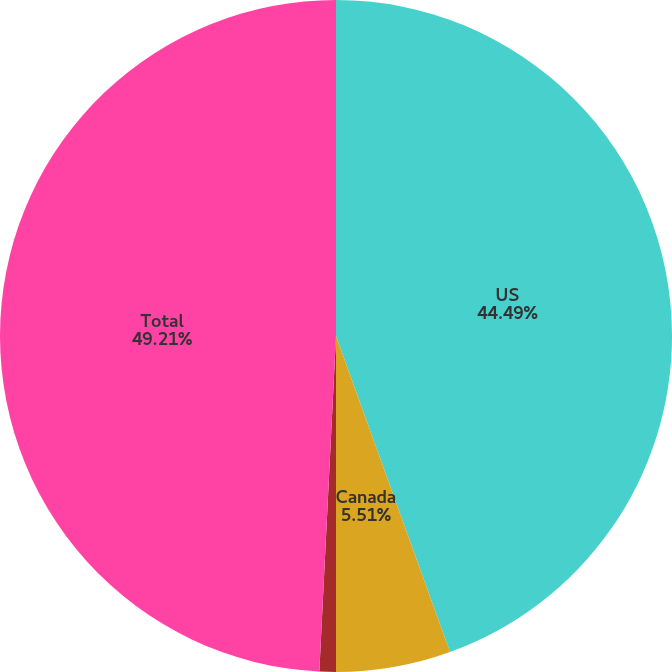<chart> <loc_0><loc_0><loc_500><loc_500><pie_chart><fcel>US<fcel>Canada<fcel>Europe<fcel>Total<nl><fcel>44.49%<fcel>5.51%<fcel>0.79%<fcel>49.21%<nl></chart> 